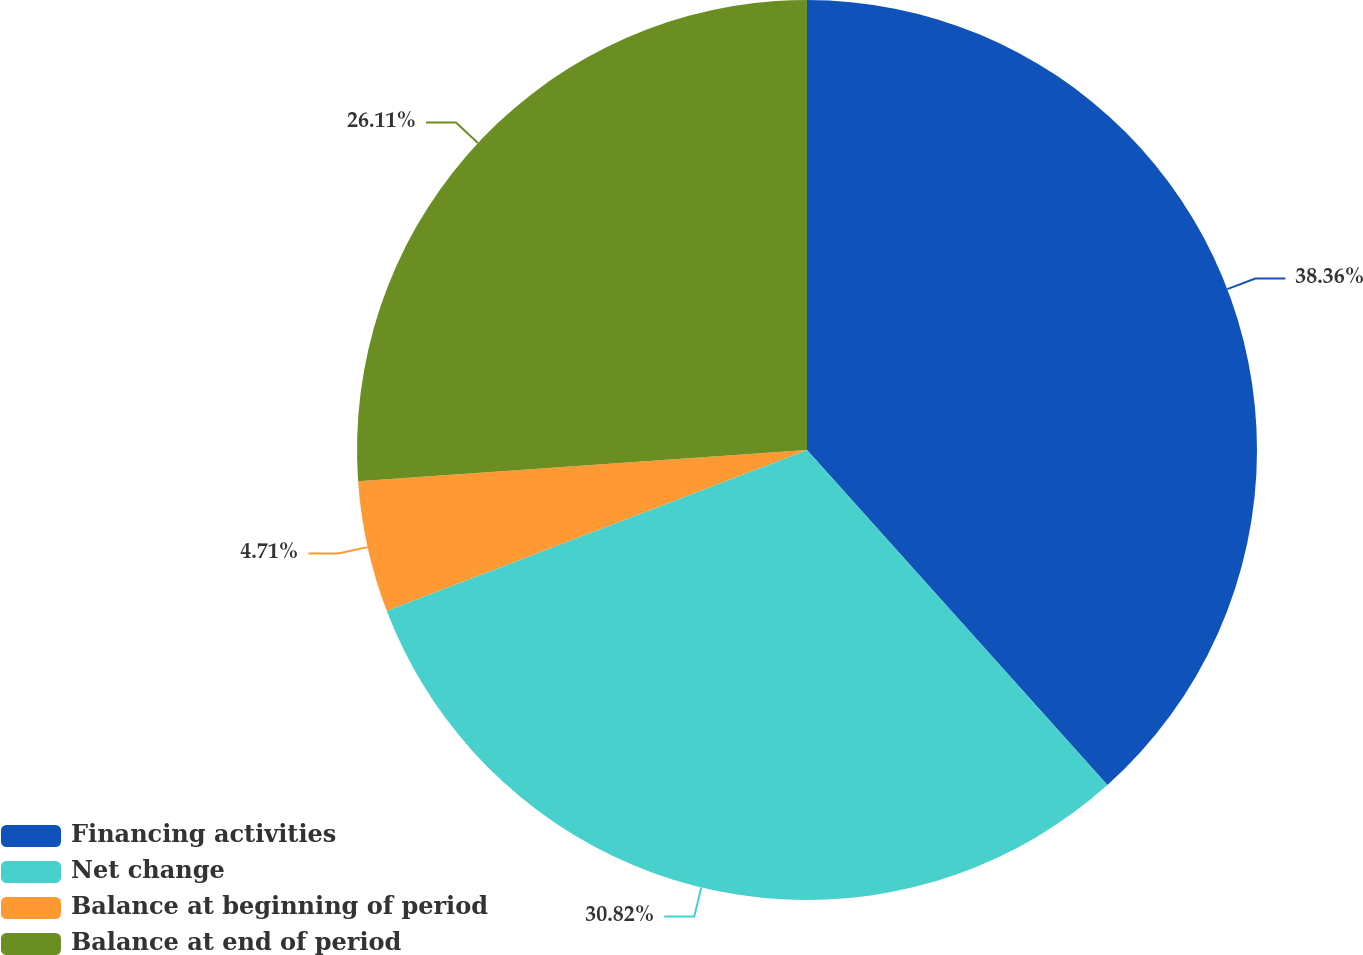<chart> <loc_0><loc_0><loc_500><loc_500><pie_chart><fcel>Financing activities<fcel>Net change<fcel>Balance at beginning of period<fcel>Balance at end of period<nl><fcel>38.37%<fcel>30.82%<fcel>4.71%<fcel>26.11%<nl></chart> 